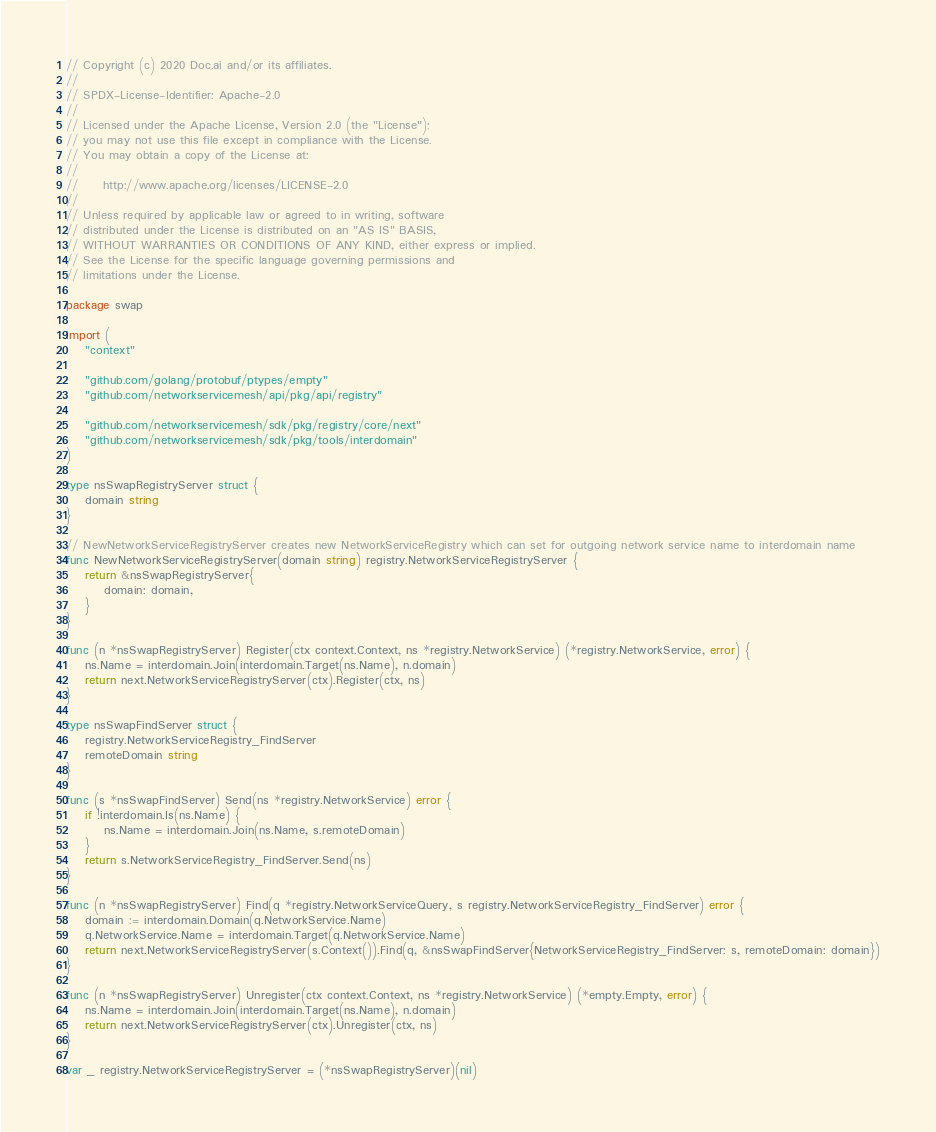Convert code to text. <code><loc_0><loc_0><loc_500><loc_500><_Go_>// Copyright (c) 2020 Doc.ai and/or its affiliates.
//
// SPDX-License-Identifier: Apache-2.0
//
// Licensed under the Apache License, Version 2.0 (the "License");
// you may not use this file except in compliance with the License.
// You may obtain a copy of the License at:
//
//     http://www.apache.org/licenses/LICENSE-2.0
//
// Unless required by applicable law or agreed to in writing, software
// distributed under the License is distributed on an "AS IS" BASIS,
// WITHOUT WARRANTIES OR CONDITIONS OF ANY KIND, either express or implied.
// See the License for the specific language governing permissions and
// limitations under the License.

package swap

import (
	"context"

	"github.com/golang/protobuf/ptypes/empty"
	"github.com/networkservicemesh/api/pkg/api/registry"

	"github.com/networkservicemesh/sdk/pkg/registry/core/next"
	"github.com/networkservicemesh/sdk/pkg/tools/interdomain"
)

type nsSwapRegistryServer struct {
	domain string
}

// NewNetworkServiceRegistryServer creates new NetworkServiceRegistry which can set for outgoing network service name to interdomain name
func NewNetworkServiceRegistryServer(domain string) registry.NetworkServiceRegistryServer {
	return &nsSwapRegistryServer{
		domain: domain,
	}
}

func (n *nsSwapRegistryServer) Register(ctx context.Context, ns *registry.NetworkService) (*registry.NetworkService, error) {
	ns.Name = interdomain.Join(interdomain.Target(ns.Name), n.domain)
	return next.NetworkServiceRegistryServer(ctx).Register(ctx, ns)
}

type nsSwapFindServer struct {
	registry.NetworkServiceRegistry_FindServer
	remoteDomain string
}

func (s *nsSwapFindServer) Send(ns *registry.NetworkService) error {
	if !interdomain.Is(ns.Name) {
		ns.Name = interdomain.Join(ns.Name, s.remoteDomain)
	}
	return s.NetworkServiceRegistry_FindServer.Send(ns)
}

func (n *nsSwapRegistryServer) Find(q *registry.NetworkServiceQuery, s registry.NetworkServiceRegistry_FindServer) error {
	domain := interdomain.Domain(q.NetworkService.Name)
	q.NetworkService.Name = interdomain.Target(q.NetworkService.Name)
	return next.NetworkServiceRegistryServer(s.Context()).Find(q, &nsSwapFindServer{NetworkServiceRegistry_FindServer: s, remoteDomain: domain})
}

func (n *nsSwapRegistryServer) Unregister(ctx context.Context, ns *registry.NetworkService) (*empty.Empty, error) {
	ns.Name = interdomain.Join(interdomain.Target(ns.Name), n.domain)
	return next.NetworkServiceRegistryServer(ctx).Unregister(ctx, ns)
}

var _ registry.NetworkServiceRegistryServer = (*nsSwapRegistryServer)(nil)
</code> 